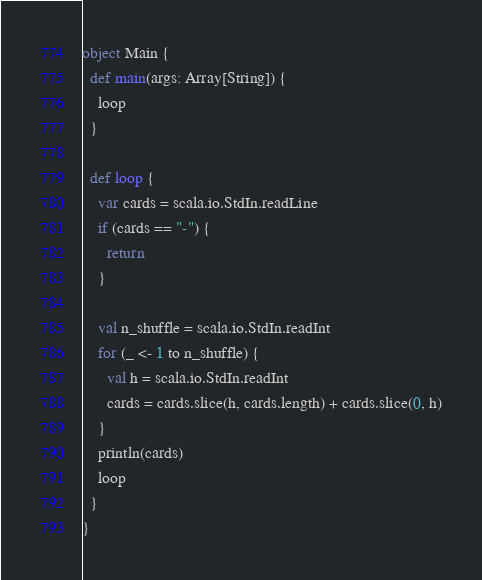Convert code to text. <code><loc_0><loc_0><loc_500><loc_500><_Scala_>object Main {
  def main(args: Array[String]) {
    loop
  }

  def loop {
    var cards = scala.io.StdIn.readLine
    if (cards == "-") {
      return
    }

    val n_shuffle = scala.io.StdIn.readInt
    for (_ <- 1 to n_shuffle) {
      val h = scala.io.StdIn.readInt
      cards = cards.slice(h, cards.length) + cards.slice(0, h)
    }
    println(cards)
    loop
  }
}</code> 